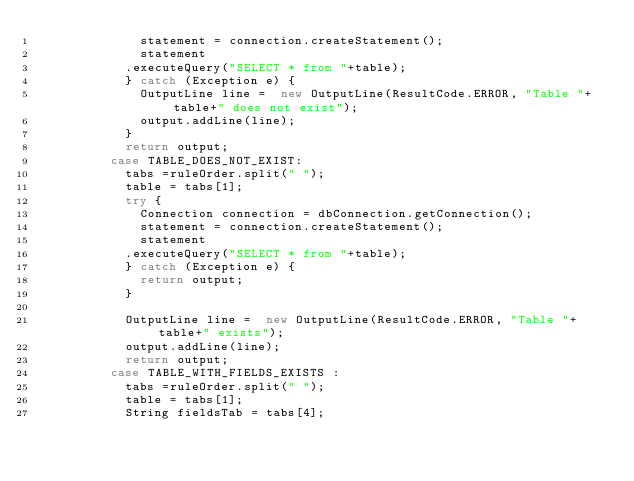Convert code to text. <code><loc_0><loc_0><loc_500><loc_500><_Java_>	      			statement = connection.createStatement();
	      			statement
						.executeQuery("SELECT * from "+table);
	      		} catch (Exception e) {
	      			OutputLine line =  new OutputLine(ResultCode.ERROR, "Table "+table+" does not exist");
	      			output.addLine(line);
	      		}
	      		return output;
	      	case TABLE_DOES_NOT_EXIST:
	      		tabs =ruleOrder.split(" ");
	      		table = tabs[1];
	      		try {
	      			Connection connection = dbConnection.getConnection();
	      			statement = connection.createStatement();
	      			statement
						.executeQuery("SELECT * from "+table);
	      		} catch (Exception e) {
	      			return output;
	      		}
			
	      		OutputLine line =  new OutputLine(ResultCode.ERROR, "Table "+table+" exists");
	      		output.addLine(line);
	      		return output; 
	      	case TABLE_WITH_FIELDS_EXISTS :
	      		tabs =ruleOrder.split(" ");
	      		table = tabs[1];
	      		String fieldsTab = tabs[4];</code> 